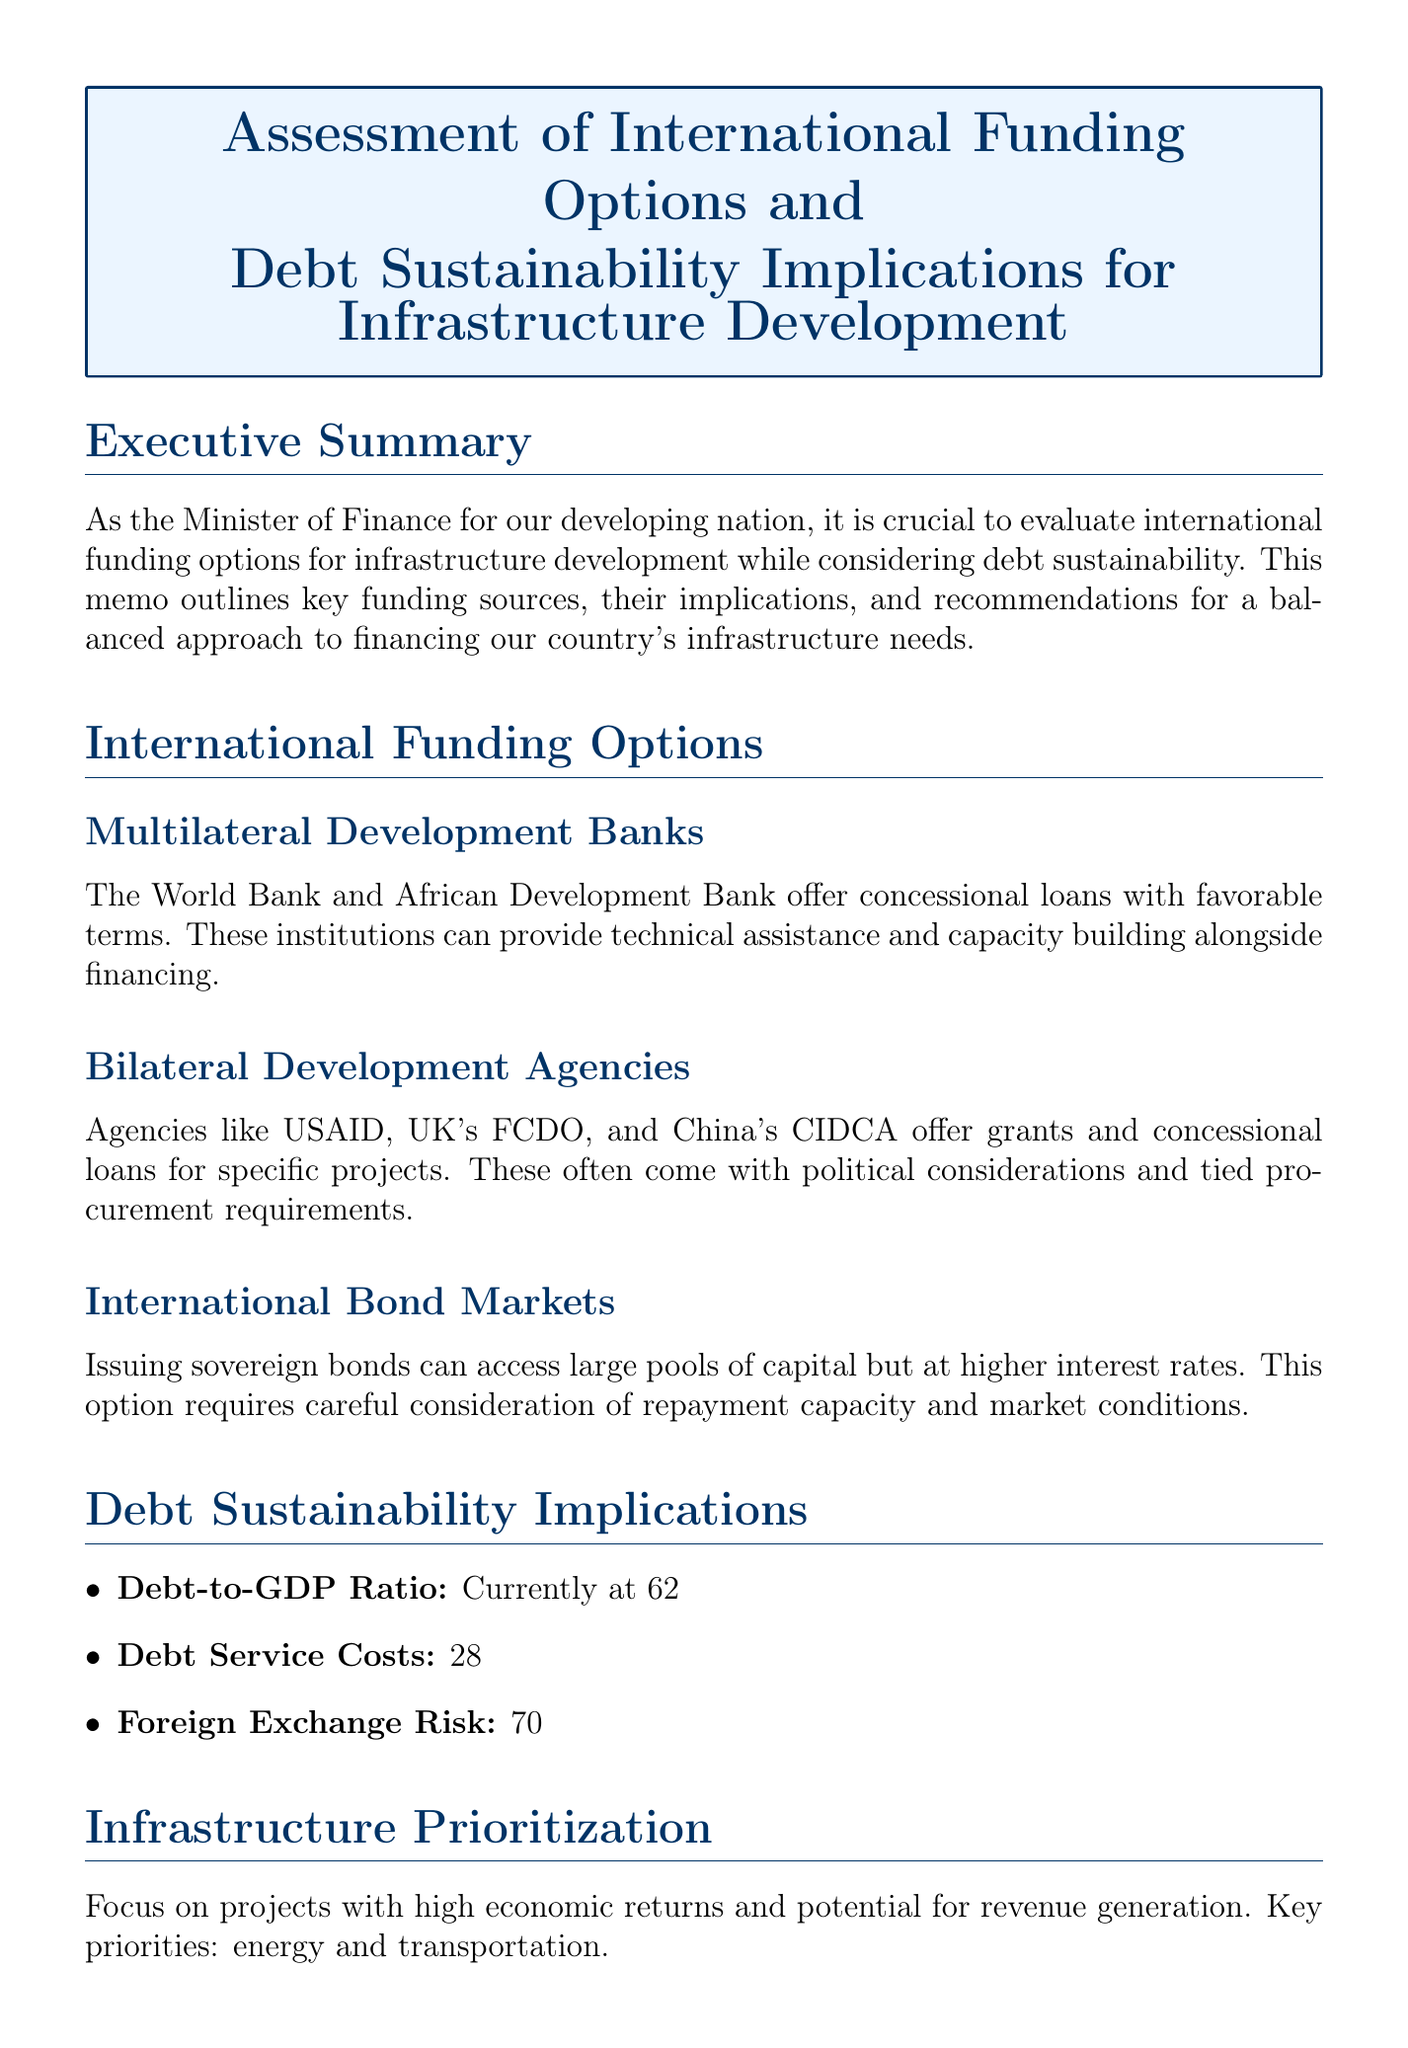what is the title of the memo? The title of the memo is stated clearly at the beginning of the document.
Answer: Assessment of International Funding Options and Debt Sustainability Implications for Infrastructure Development who offers concessional loans with favorable terms? The section on international funding options mentions specific institutions that provide favorable terms.
Answer: Multilateral Development Banks what percentage of government revenue is consumed by annual debt service? This information is found in the debt sustainability implications section discussing financial limitations.
Answer: 28% what is the current debt-to-GDP ratio? The document specifies the current ratio needed for understanding fiscal health.
Answer: 62% what recommendations are made for debt management? The recommendations section outlines strategies for improving management of funds.
Answer: Implement a robust debt management strategy which sectors are prioritized for infrastructure development? The infrastructure prioritization section identifies key areas for investment in development.
Answer: Energy and transportation how many years are the maturities for the World Bank’s IDA loans? The specific period for loan repayment is mentioned as a detail in the funding options section.
Answer: 38 years which agency provided funding for road infrastructure projects with low interest rates? The details provided in the bilateral development agencies subsection include specific examples.
Answer: Japan International Cooperation Agency (JICA) what is suggested as a next step in funding strategy discussions? The next steps itemizes actions to be taken towards infrastructure financing.
Answer: Convene a meeting with the National Economic Council 